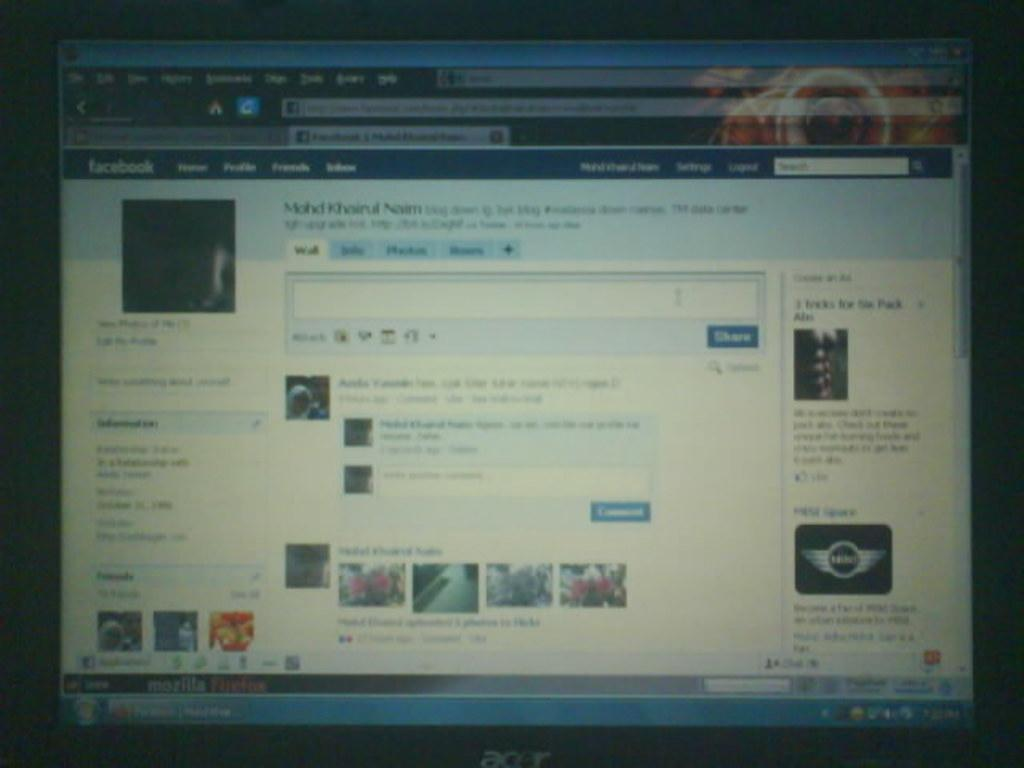What is the main object in the image? There is a screen in the image. What can be seen on the screen? Pictures and text or writing are visible on the screen. Where is the beetle crawling on the screen in the image? There is no beetle present on the screen in the image. What is the neck size of the person in the image? There is no person present in the image, so it is impossible to determine the neck size. 